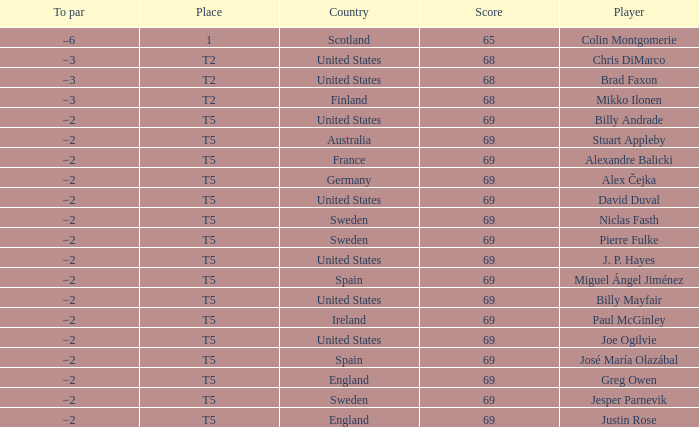What place did Paul McGinley finish in? T5. 